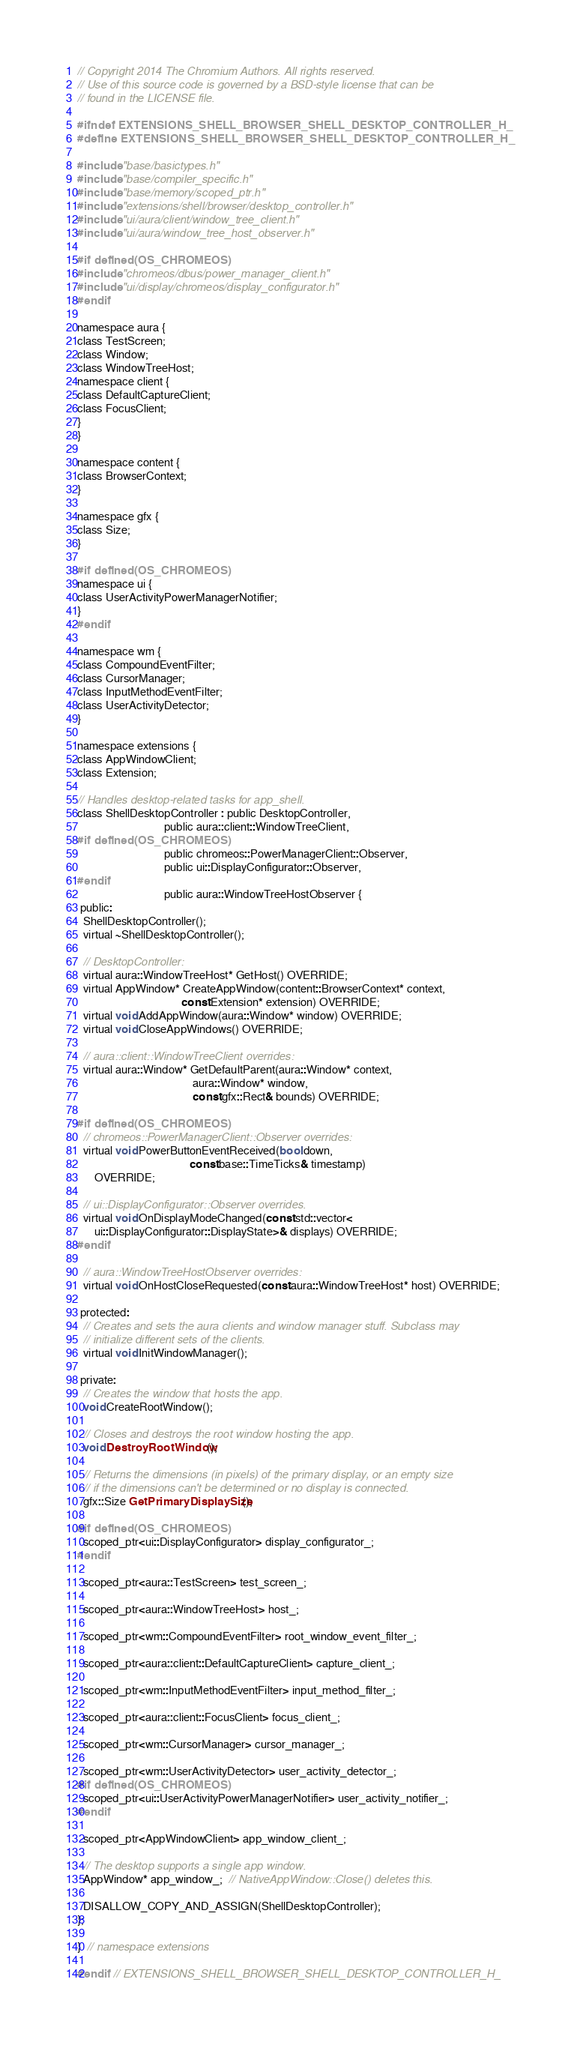<code> <loc_0><loc_0><loc_500><loc_500><_C_>// Copyright 2014 The Chromium Authors. All rights reserved.
// Use of this source code is governed by a BSD-style license that can be
// found in the LICENSE file.

#ifndef EXTENSIONS_SHELL_BROWSER_SHELL_DESKTOP_CONTROLLER_H_
#define EXTENSIONS_SHELL_BROWSER_SHELL_DESKTOP_CONTROLLER_H_

#include "base/basictypes.h"
#include "base/compiler_specific.h"
#include "base/memory/scoped_ptr.h"
#include "extensions/shell/browser/desktop_controller.h"
#include "ui/aura/client/window_tree_client.h"
#include "ui/aura/window_tree_host_observer.h"

#if defined(OS_CHROMEOS)
#include "chromeos/dbus/power_manager_client.h"
#include "ui/display/chromeos/display_configurator.h"
#endif

namespace aura {
class TestScreen;
class Window;
class WindowTreeHost;
namespace client {
class DefaultCaptureClient;
class FocusClient;
}
}

namespace content {
class BrowserContext;
}

namespace gfx {
class Size;
}

#if defined(OS_CHROMEOS)
namespace ui {
class UserActivityPowerManagerNotifier;
}
#endif

namespace wm {
class CompoundEventFilter;
class CursorManager;
class InputMethodEventFilter;
class UserActivityDetector;
}

namespace extensions {
class AppWindowClient;
class Extension;

// Handles desktop-related tasks for app_shell.
class ShellDesktopController : public DesktopController,
                               public aura::client::WindowTreeClient,
#if defined(OS_CHROMEOS)
                               public chromeos::PowerManagerClient::Observer,
                               public ui::DisplayConfigurator::Observer,
#endif
                               public aura::WindowTreeHostObserver {
 public:
  ShellDesktopController();
  virtual ~ShellDesktopController();

  // DesktopController:
  virtual aura::WindowTreeHost* GetHost() OVERRIDE;
  virtual AppWindow* CreateAppWindow(content::BrowserContext* context,
                                     const Extension* extension) OVERRIDE;
  virtual void AddAppWindow(aura::Window* window) OVERRIDE;
  virtual void CloseAppWindows() OVERRIDE;

  // aura::client::WindowTreeClient overrides:
  virtual aura::Window* GetDefaultParent(aura::Window* context,
                                         aura::Window* window,
                                         const gfx::Rect& bounds) OVERRIDE;

#if defined(OS_CHROMEOS)
  // chromeos::PowerManagerClient::Observer overrides:
  virtual void PowerButtonEventReceived(bool down,
                                        const base::TimeTicks& timestamp)
      OVERRIDE;

  // ui::DisplayConfigurator::Observer overrides.
  virtual void OnDisplayModeChanged(const std::vector<
      ui::DisplayConfigurator::DisplayState>& displays) OVERRIDE;
#endif

  // aura::WindowTreeHostObserver overrides:
  virtual void OnHostCloseRequested(const aura::WindowTreeHost* host) OVERRIDE;

 protected:
  // Creates and sets the aura clients and window manager stuff. Subclass may
  // initialize different sets of the clients.
  virtual void InitWindowManager();

 private:
  // Creates the window that hosts the app.
  void CreateRootWindow();

  // Closes and destroys the root window hosting the app.
  void DestroyRootWindow();

  // Returns the dimensions (in pixels) of the primary display, or an empty size
  // if the dimensions can't be determined or no display is connected.
  gfx::Size GetPrimaryDisplaySize();

#if defined(OS_CHROMEOS)
  scoped_ptr<ui::DisplayConfigurator> display_configurator_;
#endif

  scoped_ptr<aura::TestScreen> test_screen_;

  scoped_ptr<aura::WindowTreeHost> host_;

  scoped_ptr<wm::CompoundEventFilter> root_window_event_filter_;

  scoped_ptr<aura::client::DefaultCaptureClient> capture_client_;

  scoped_ptr<wm::InputMethodEventFilter> input_method_filter_;

  scoped_ptr<aura::client::FocusClient> focus_client_;

  scoped_ptr<wm::CursorManager> cursor_manager_;

  scoped_ptr<wm::UserActivityDetector> user_activity_detector_;
#if defined(OS_CHROMEOS)
  scoped_ptr<ui::UserActivityPowerManagerNotifier> user_activity_notifier_;
#endif

  scoped_ptr<AppWindowClient> app_window_client_;

  // The desktop supports a single app window.
  AppWindow* app_window_;  // NativeAppWindow::Close() deletes this.

  DISALLOW_COPY_AND_ASSIGN(ShellDesktopController);
};

}  // namespace extensions

#endif  // EXTENSIONS_SHELL_BROWSER_SHELL_DESKTOP_CONTROLLER_H_
</code> 